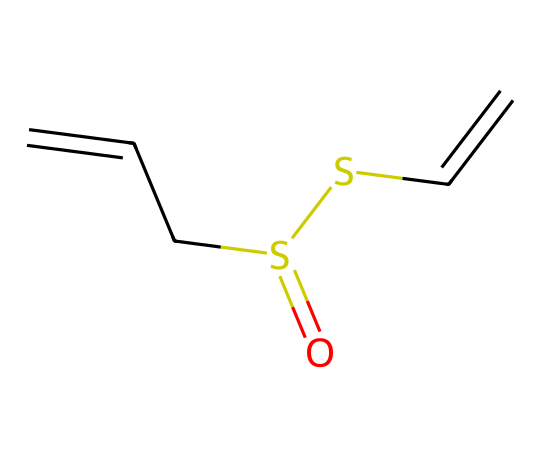What is the molecular formula of allicin? To determine the molecular formula, count the number of each type of atom present in the SMILES representation. The representation indicates one sulfur (S), two carbon double bonds (C), and oxygen (O) connected in a certain way, leading to C6H10OS2.
Answer: C6H10OS2 How many double bonds are present in allicin? Observing the SMILES structure, we identify the two 'C=C' parts, which indicate there are two double bonds between carbon atoms in the structure.
Answer: 2 What functional groups are present in allicin? Analyzing the SMILES representation, we see a sulfoxide group (due to the sulfur and oxygen present) and an alkene group (due to the double bonds between the carbon atoms).
Answer: sulfoxide and alkene What is the total number of carbon atoms in allicin? Within the SMILES structure, each 'C' represents a carbon atom. By counting them, we find there are six carbon atoms in total.
Answer: 6 Why does allicin have a distinctive aroma? The presence of sulfur (S) leads to the characteristic smell associated with garlic compounds, particularly the sulfur-containing moieties, because they can easily volatilize and are detectable at low concentrations.
Answer: sulfur How many sulfur atoms are part of the allicin structure? In the SMILES notation, there is a clear indication of two sulfur atoms present in the compound through the 'S' symbols.
Answer: 2 